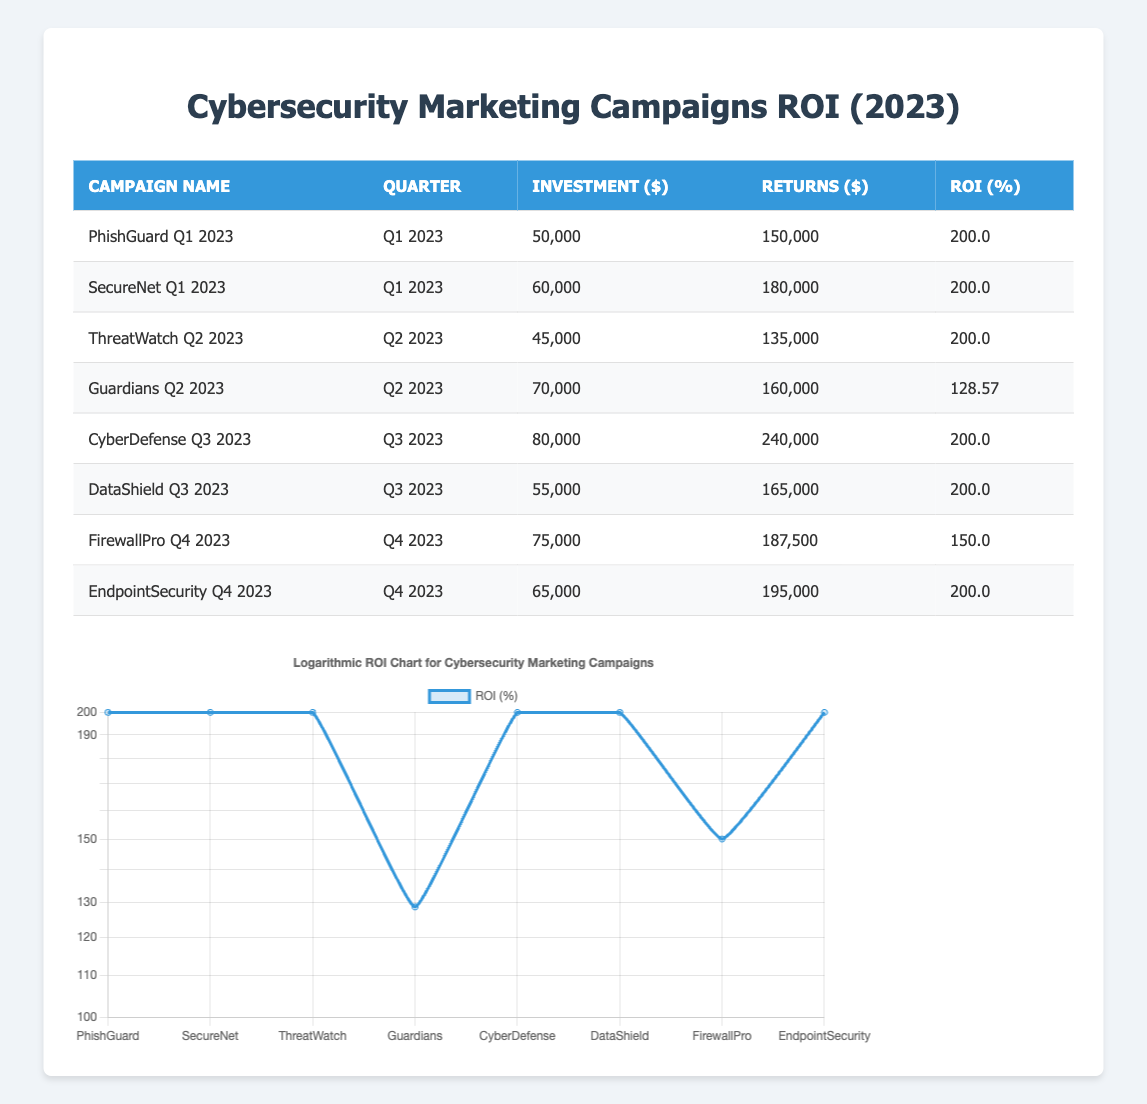What is the ROI for the PhishGuard Q1 2023 campaign? The table indicates that the ROI for the PhishGuard Q1 2023 campaign is listed under the "ROI (%)" column. It shows a value of 200.0
Answer: 200.0 Which campaign had the highest returns in Q3 2023? In the third quarter of 2023, the returns for CyberDefense are 240,000, which is higher than DataShield's returns of 165,000. Thus, CyberDefense had the highest returns in that quarter.
Answer: CyberDefense What is the total investment across all campaigns in Q2 2023? The investments for Q2 2023 are from ThreatWatch (45,000) and Guardians (70,000). Adding these gives a total investment of 45,000 + 70,000 = 115,000.
Answer: 115,000 Is the ROI for EndpointSecurity Q4 2023 higher than that of FirewallPro Q4 2023? The ROI for EndpointSecurity is 200.0, while for FirewallPro it is 150.0. Since 200.0 is greater than 150.0, the answer is true.
Answer: Yes What is the average ROI for campaigns in Q1 2023? The campaigns for Q1 2023 are PhishGuard and SecureNet, both with an ROI of 200.0. The average ROI calculation is (200.0 + 200.0) / 2 = 200.0.
Answer: 200.0 Which campaign had the lowest ROI, and what was that value? Looking at the table, the lowest ROI is listed under Guardians Q2 2023, which has an ROI of 128.57. Therefore, the campaign with the lowest ROI is Guardians, with 128.57 as the value.
Answer: Guardians, 128.57 What is the difference in investment amount between CyberDefense Q3 2023 and DataShield Q3 2023? For CyberDefense, the investment is 80,000, and for DataShield, it is 55,000. The difference in investment is calculated as 80,000 - 55,000 = 25,000.
Answer: 25,000 Was the total return for SecureNet Q1 2023 higher than 150,000? The returns for SecureNet Q1 2023 are 180,000, which is indeed higher than 150,000. Thus, the statement is true.
Answer: Yes What percentage of campaigns had an ROI of 200.0? The campaigns with an ROI of 200.0 are PhishGuard Q1, SecureNet Q1, ThreatWatch Q2, CyberDefense Q3, DataShield Q3, and EndpointSecurity Q4. There are 6 campaigns with this ROI out of a total of 8 campaigns, so the percentage is (6 / 8) * 100 = 75%.
Answer: 75% 